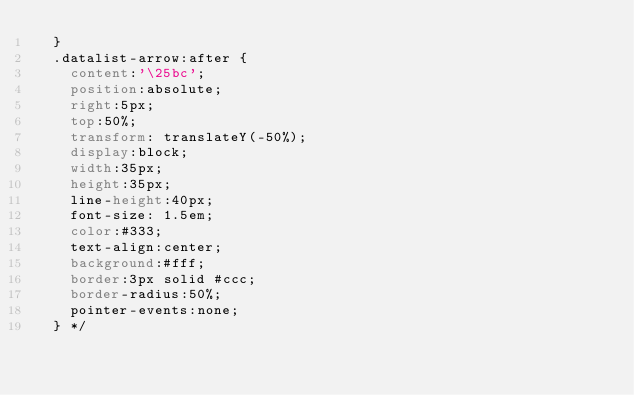<code> <loc_0><loc_0><loc_500><loc_500><_CSS_>  }
  .datalist-arrow:after {
    content:'\25bc';
    position:absolute;
    right:5px;
    top:50%;
    transform: translateY(-50%);
    display:block;
    width:35px;
    height:35px;
    line-height:40px;
    font-size: 1.5em;
    color:#333;
    text-align:center;
    background:#fff;
    border:3px solid #ccc;
    border-radius:50%;
    pointer-events:none;
  } */</code> 